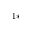<formula> <loc_0><loc_0><loc_500><loc_500>^ { 1 \ast }</formula> 